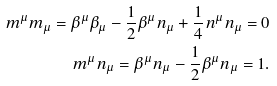Convert formula to latex. <formula><loc_0><loc_0><loc_500><loc_500>m ^ { \mu } m _ { \mu } = \beta ^ { \mu } \beta _ { \mu } - \frac { 1 } { 2 } \beta ^ { \mu } n _ { \mu } + \frac { 1 } { 4 } n ^ { \mu } n _ { \mu } = 0 \\ m ^ { \mu } n _ { \mu } = \beta ^ { \mu } n _ { \mu } - \frac { 1 } { 2 } \beta ^ { \mu } n _ { \mu } = 1 .</formula> 